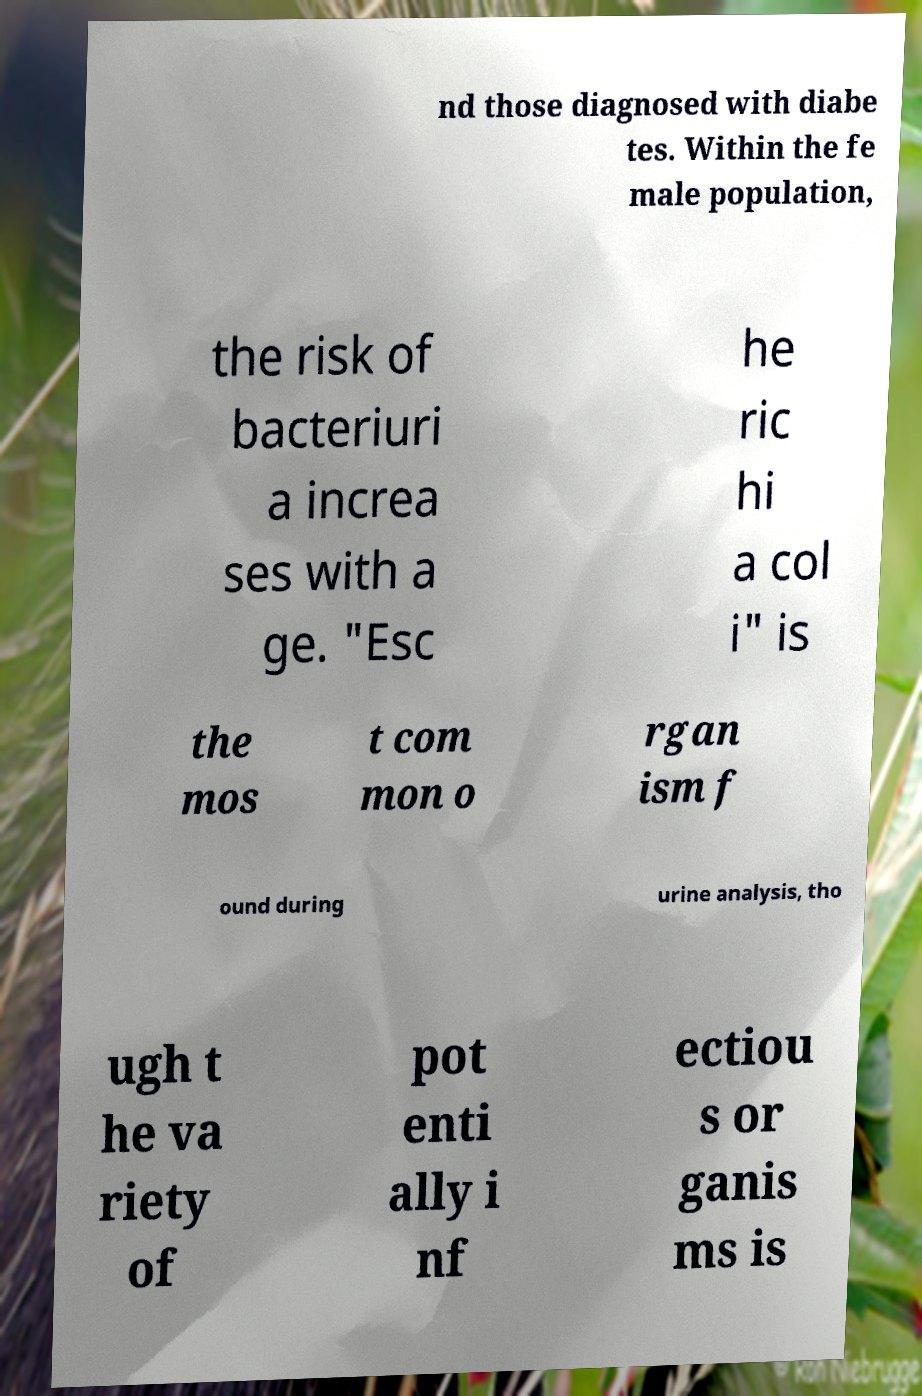Could you assist in decoding the text presented in this image and type it out clearly? nd those diagnosed with diabe tes. Within the fe male population, the risk of bacteriuri a increa ses with a ge. "Esc he ric hi a col i" is the mos t com mon o rgan ism f ound during urine analysis, tho ugh t he va riety of pot enti ally i nf ectiou s or ganis ms is 